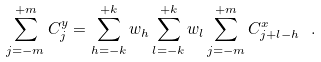<formula> <loc_0><loc_0><loc_500><loc_500>\sum _ { j = - m } ^ { + m } C _ { j } ^ { y } = \sum _ { h = - k } ^ { + k } w _ { h } \sum _ { l = - k } ^ { + k } w _ { l } \sum _ { j = - m } ^ { + m } C _ { j + l - h } ^ { x } \ .</formula> 